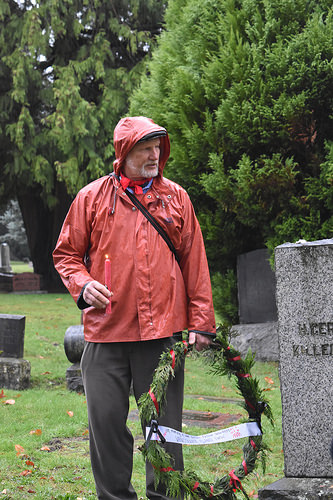<image>
Is the man behind the candle? Yes. From this viewpoint, the man is positioned behind the candle, with the candle partially or fully occluding the man. 